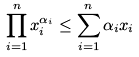<formula> <loc_0><loc_0><loc_500><loc_500>\prod _ { i = 1 } ^ { n } x _ { i } ^ { \alpha _ { i } } \leq \sum _ { i = 1 } ^ { n } \alpha _ { i } x _ { i }</formula> 